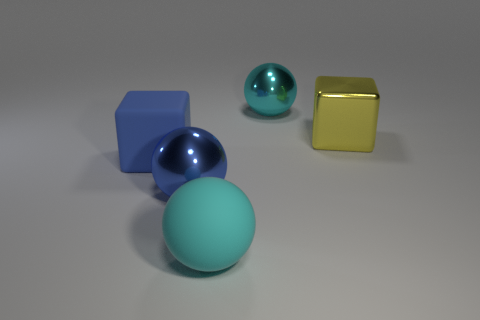What number of large blue balls are made of the same material as the big yellow block?
Your answer should be compact. 1. There is a big blue matte cube; how many blue balls are left of it?
Make the answer very short. 0. How big is the blue matte thing?
Make the answer very short. Large. There is another matte object that is the same size as the blue matte object; what is its color?
Keep it short and to the point. Cyan. Are there any matte balls that have the same color as the big matte block?
Your answer should be compact. No. What is the material of the blue block?
Ensure brevity in your answer.  Rubber. What number of big metal things are there?
Keep it short and to the point. 3. There is a rubber thing that is right of the blue ball; is its color the same as the large metal ball in front of the rubber block?
Your answer should be compact. No. What size is the thing that is the same color as the matte sphere?
Offer a very short reply. Large. How many other things are there of the same size as the yellow metal cube?
Provide a short and direct response. 4. 